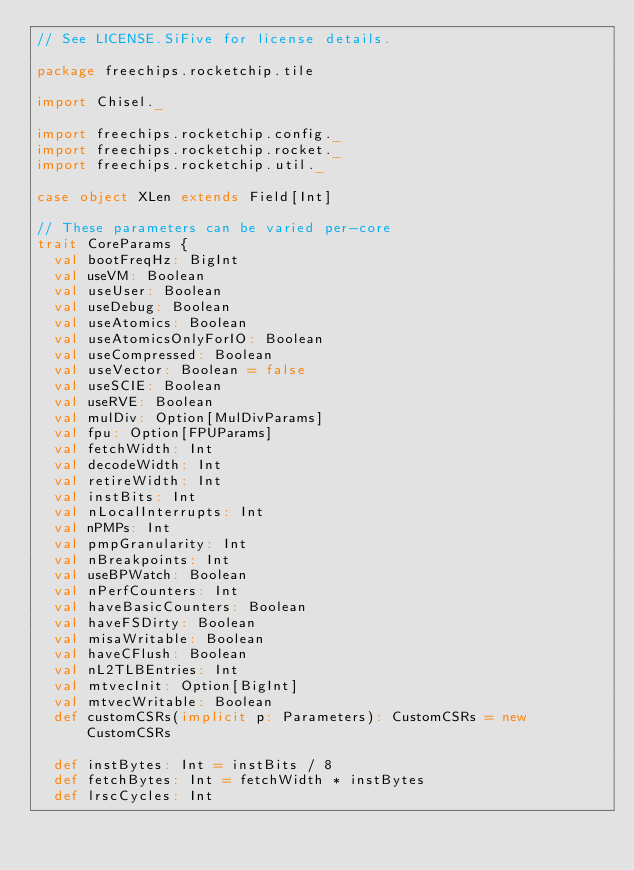Convert code to text. <code><loc_0><loc_0><loc_500><loc_500><_Scala_>// See LICENSE.SiFive for license details.

package freechips.rocketchip.tile

import Chisel._

import freechips.rocketchip.config._
import freechips.rocketchip.rocket._
import freechips.rocketchip.util._

case object XLen extends Field[Int]

// These parameters can be varied per-core
trait CoreParams {
  val bootFreqHz: BigInt
  val useVM: Boolean
  val useUser: Boolean
  val useDebug: Boolean
  val useAtomics: Boolean
  val useAtomicsOnlyForIO: Boolean
  val useCompressed: Boolean
  val useVector: Boolean = false
  val useSCIE: Boolean
  val useRVE: Boolean
  val mulDiv: Option[MulDivParams]
  val fpu: Option[FPUParams]
  val fetchWidth: Int
  val decodeWidth: Int
  val retireWidth: Int
  val instBits: Int
  val nLocalInterrupts: Int
  val nPMPs: Int
  val pmpGranularity: Int
  val nBreakpoints: Int
  val useBPWatch: Boolean
  val nPerfCounters: Int
  val haveBasicCounters: Boolean
  val haveFSDirty: Boolean
  val misaWritable: Boolean
  val haveCFlush: Boolean
  val nL2TLBEntries: Int
  val mtvecInit: Option[BigInt]
  val mtvecWritable: Boolean
  def customCSRs(implicit p: Parameters): CustomCSRs = new CustomCSRs

  def instBytes: Int = instBits / 8
  def fetchBytes: Int = fetchWidth * instBytes
  def lrscCycles: Int
</code> 